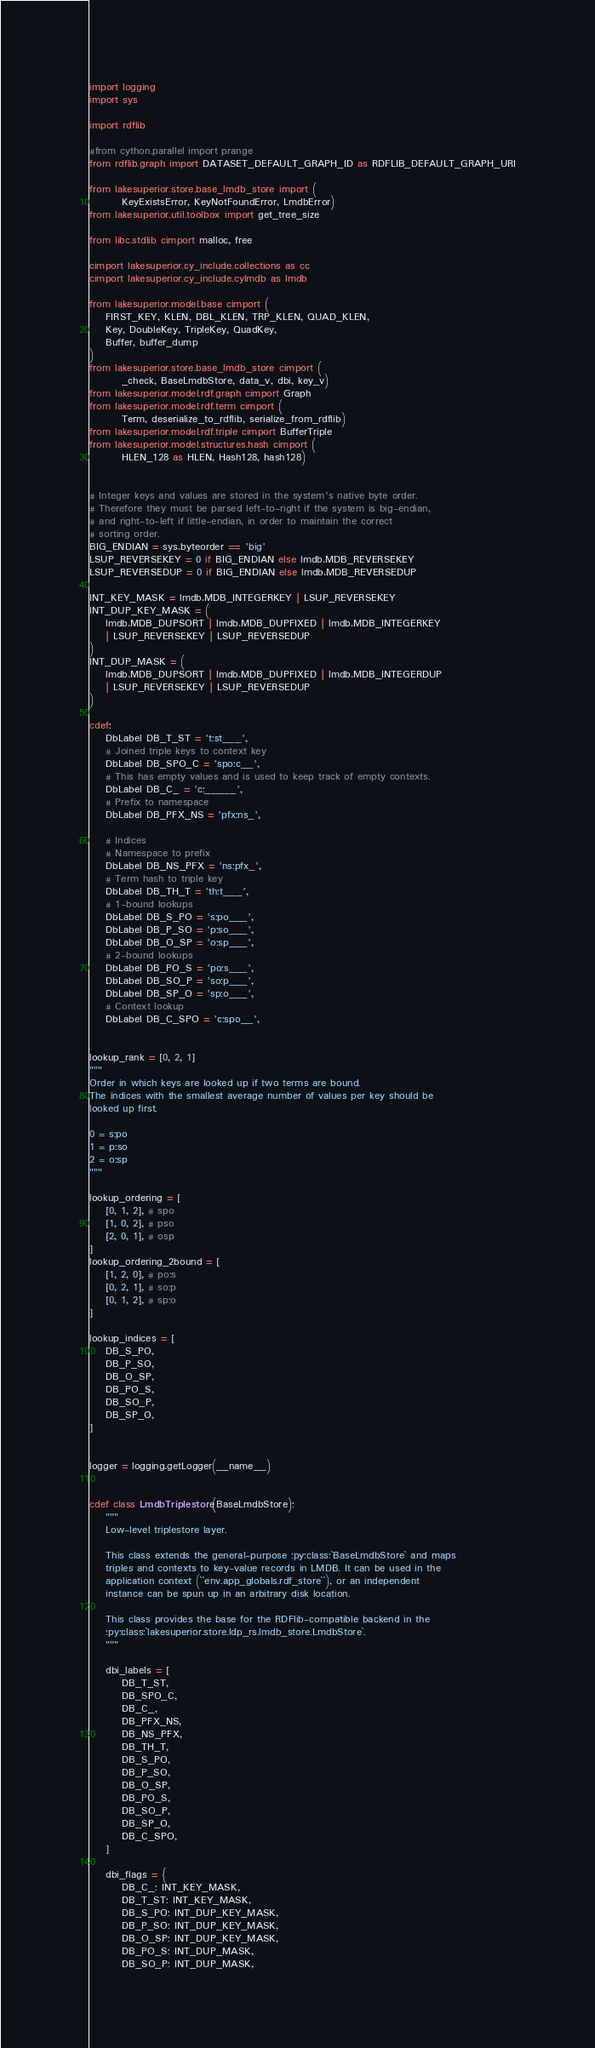Convert code to text. <code><loc_0><loc_0><loc_500><loc_500><_Cython_>import logging
import sys

import rdflib

#from cython.parallel import prange
from rdflib.graph import DATASET_DEFAULT_GRAPH_ID as RDFLIB_DEFAULT_GRAPH_URI

from lakesuperior.store.base_lmdb_store import (
        KeyExistsError, KeyNotFoundError, LmdbError)
from lakesuperior.util.toolbox import get_tree_size

from libc.stdlib cimport malloc, free

cimport lakesuperior.cy_include.collections as cc
cimport lakesuperior.cy_include.cylmdb as lmdb

from lakesuperior.model.base cimport (
    FIRST_KEY, KLEN, DBL_KLEN, TRP_KLEN, QUAD_KLEN,
    Key, DoubleKey, TripleKey, QuadKey,
    Buffer, buffer_dump
)
from lakesuperior.store.base_lmdb_store cimport (
        _check, BaseLmdbStore, data_v, dbi, key_v)
from lakesuperior.model.rdf.graph cimport Graph
from lakesuperior.model.rdf.term cimport (
        Term, deserialize_to_rdflib, serialize_from_rdflib)
from lakesuperior.model.rdf.triple cimport BufferTriple
from lakesuperior.model.structures.hash cimport (
        HLEN_128 as HLEN, Hash128, hash128)


# Integer keys and values are stored in the system's native byte order.
# Therefore they must be parsed left-to-right if the system is big-endian,
# and right-to-left if little-endian, in order to maintain the correct
# sorting order.
BIG_ENDIAN = sys.byteorder == 'big'
LSUP_REVERSEKEY = 0 if BIG_ENDIAN else lmdb.MDB_REVERSEKEY
LSUP_REVERSEDUP = 0 if BIG_ENDIAN else lmdb.MDB_REVERSEDUP

INT_KEY_MASK = lmdb.MDB_INTEGERKEY | LSUP_REVERSEKEY
INT_DUP_KEY_MASK = (
    lmdb.MDB_DUPSORT | lmdb.MDB_DUPFIXED | lmdb.MDB_INTEGERKEY
    | LSUP_REVERSEKEY | LSUP_REVERSEDUP
)
INT_DUP_MASK = (
    lmdb.MDB_DUPSORT | lmdb.MDB_DUPFIXED | lmdb.MDB_INTEGERDUP
    | LSUP_REVERSEKEY | LSUP_REVERSEDUP
)

cdef:
    DbLabel DB_T_ST = 't:st___',
    # Joined triple keys to context key
    DbLabel DB_SPO_C = 'spo:c__',
    # This has empty values and is used to keep track of empty contexts.
    DbLabel DB_C_ = 'c:_____',
    # Prefix to namespace
    DbLabel DB_PFX_NS = 'pfx:ns_',

    # Indices
    # Namespace to prefix
    DbLabel DB_NS_PFX = 'ns:pfx_',
    # Term hash to triple key
    DbLabel DB_TH_T = 'th:t___',
    # 1-bound lookups
    DbLabel DB_S_PO = 's:po___',
    DbLabel DB_P_SO = 'p:so___',
    DbLabel DB_O_SP = 'o:sp___',
    # 2-bound lookups
    DbLabel DB_PO_S = 'po:s___',
    DbLabel DB_SO_P = 'so:p___',
    DbLabel DB_SP_O = 'sp:o___',
    # Context lookup
    DbLabel DB_C_SPO = 'c:spo__',


lookup_rank = [0, 2, 1]
"""
Order in which keys are looked up if two terms are bound.
The indices with the smallest average number of values per key should be
looked up first.

0 = s:po
1 = p:so
2 = o:sp
"""

lookup_ordering = [
    [0, 1, 2], # spo
    [1, 0, 2], # pso
    [2, 0, 1], # osp
]
lookup_ordering_2bound = [
    [1, 2, 0], # po:s
    [0, 2, 1], # so:p
    [0, 1, 2], # sp:o
]

lookup_indices = [
    DB_S_PO,
    DB_P_SO,
    DB_O_SP,
    DB_PO_S,
    DB_SO_P,
    DB_SP_O,
]


logger = logging.getLogger(__name__)


cdef class LmdbTriplestore(BaseLmdbStore):
    """
    Low-level triplestore layer.

    This class extends the general-purpose :py:class:`BaseLmdbStore` and maps
    triples and contexts to key-value records in LMDB. It can be used in the
    application context (``env.app_globals.rdf_store``), or an independent
    instance can be spun up in an arbitrary disk location.

    This class provides the base for the RDFlib-compatible backend in the
    :py:class:`lakesuperior.store.ldp_rs.lmdb_store.LmdbStore`.
    """

    dbi_labels = [
        DB_T_ST,
        DB_SPO_C,
        DB_C_,
        DB_PFX_NS,
        DB_NS_PFX,
        DB_TH_T,
        DB_S_PO,
        DB_P_SO,
        DB_O_SP,
        DB_PO_S,
        DB_SO_P,
        DB_SP_O,
        DB_C_SPO,
    ]

    dbi_flags = {
        DB_C_: INT_KEY_MASK,
        DB_T_ST: INT_KEY_MASK,
        DB_S_PO: INT_DUP_KEY_MASK,
        DB_P_SO: INT_DUP_KEY_MASK,
        DB_O_SP: INT_DUP_KEY_MASK,
        DB_PO_S: INT_DUP_MASK,
        DB_SO_P: INT_DUP_MASK,</code> 